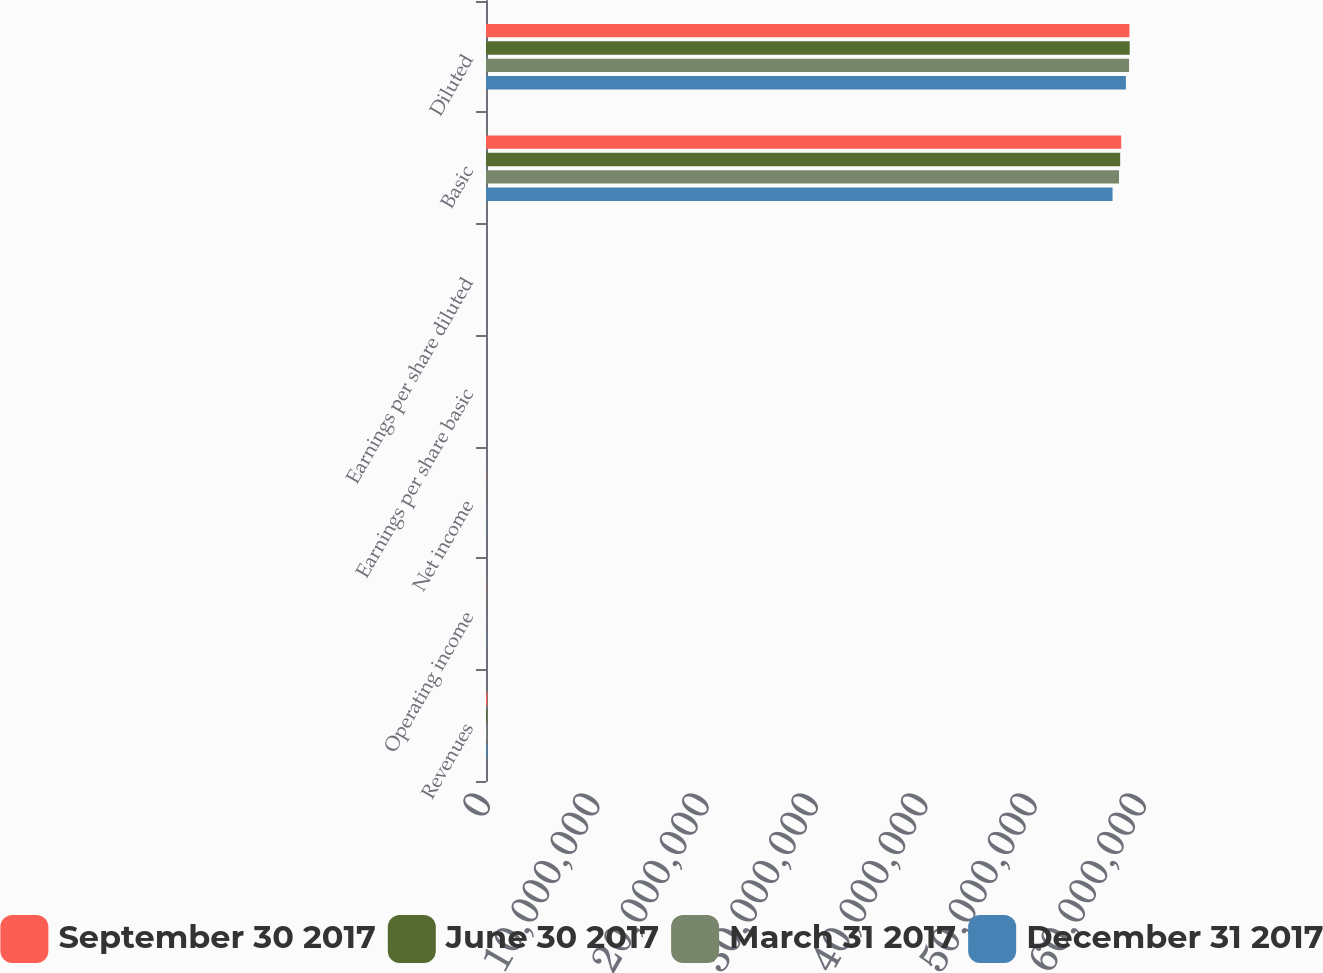Convert chart to OTSL. <chart><loc_0><loc_0><loc_500><loc_500><stacked_bar_chart><ecel><fcel>Revenues<fcel>Operating income<fcel>Net income<fcel>Earnings per share basic<fcel>Earnings per share diluted<fcel>Basic<fcel>Diluted<nl><fcel>September 30 2017<fcel>114025<fcel>19434<fcel>12905<fcel>0.22<fcel>0.22<fcel>5.81001e+07<fcel>5.88503e+07<nl><fcel>June 30 2017<fcel>101287<fcel>11437<fcel>14067<fcel>0.24<fcel>0.24<fcel>5.80032e+07<fcel>5.88735e+07<nl><fcel>March 31 2017<fcel>98227<fcel>9089<fcel>14221<fcel>0.24<fcel>0.24<fcel>5.78989e+07<fcel>5.88164e+07<nl><fcel>December 31 2017<fcel>119508<fcel>38665<fcel>25614<fcel>0.44<fcel>0.43<fcel>5.73072e+07<fcel>5.8526e+07<nl></chart> 